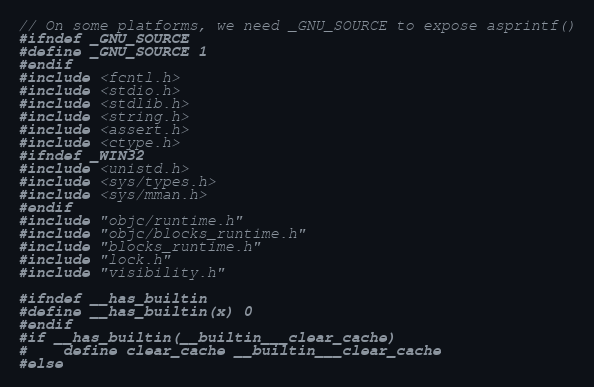<code> <loc_0><loc_0><loc_500><loc_500><_C_>// On some platforms, we need _GNU_SOURCE to expose asprintf()
#ifndef _GNU_SOURCE
#define _GNU_SOURCE 1
#endif
#include <fcntl.h>
#include <stdio.h>
#include <stdlib.h>
#include <string.h>
#include <assert.h>
#include <ctype.h>
#ifndef _WIN32
#include <unistd.h>
#include <sys/types.h>
#include <sys/mman.h>
#endif
#include "objc/runtime.h"
#include "objc/blocks_runtime.h"
#include "blocks_runtime.h"
#include "lock.h"
#include "visibility.h"

#ifndef __has_builtin
#define __has_builtin(x) 0
#endif
#if __has_builtin(__builtin___clear_cache)
#	define clear_cache __builtin___clear_cache
#else</code> 